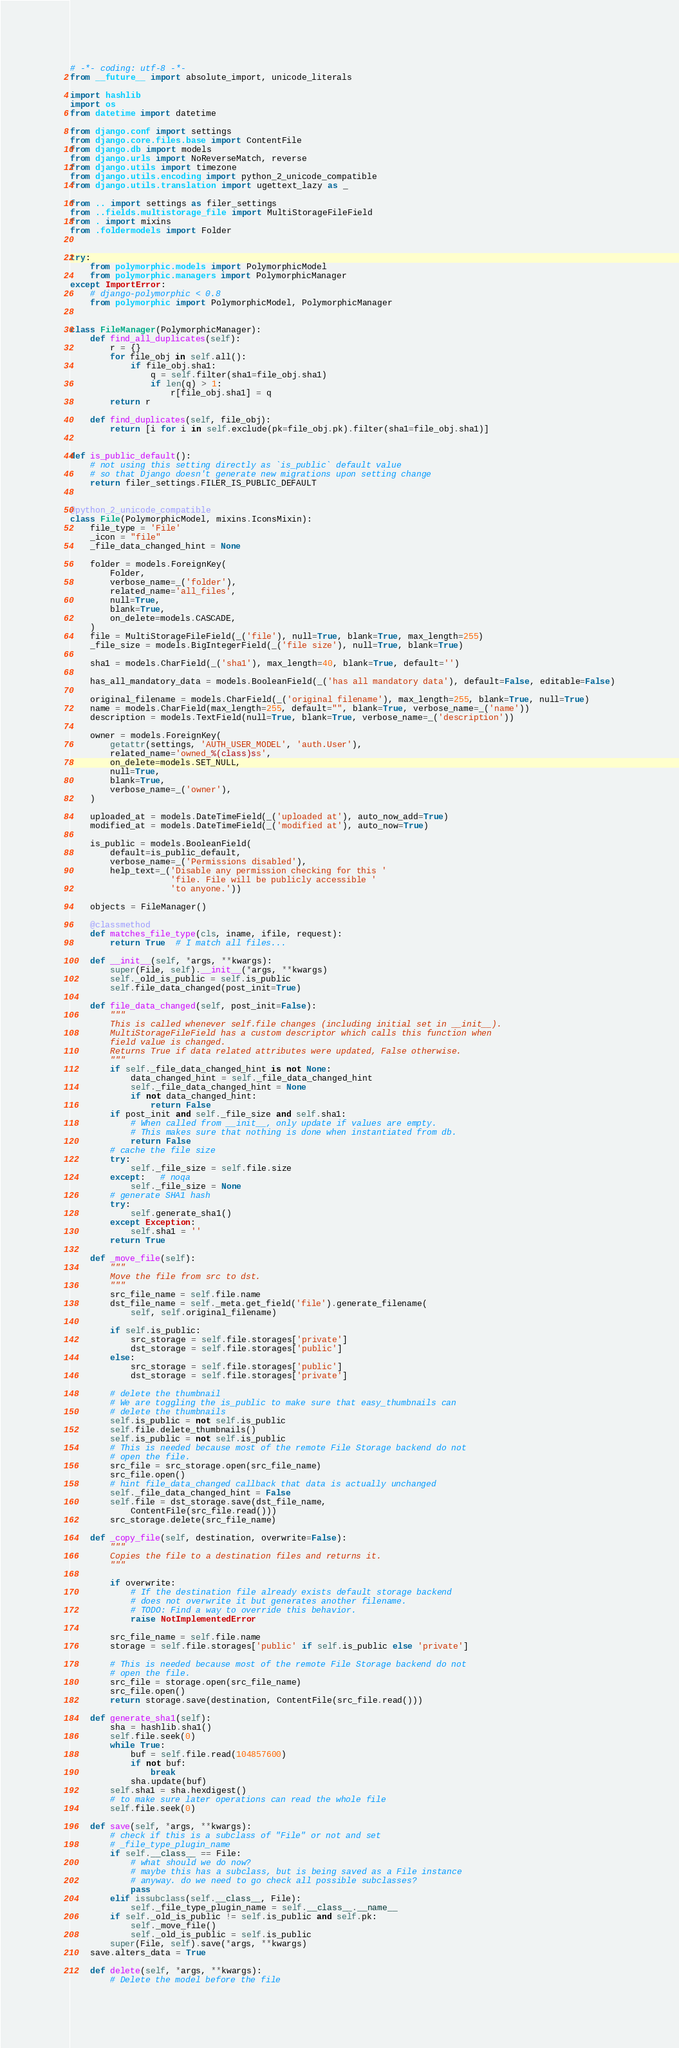<code> <loc_0><loc_0><loc_500><loc_500><_Python_># -*- coding: utf-8 -*-
from __future__ import absolute_import, unicode_literals

import hashlib
import os
from datetime import datetime

from django.conf import settings
from django.core.files.base import ContentFile
from django.db import models
from django.urls import NoReverseMatch, reverse
from django.utils import timezone
from django.utils.encoding import python_2_unicode_compatible
from django.utils.translation import ugettext_lazy as _

from .. import settings as filer_settings
from ..fields.multistorage_file import MultiStorageFileField
from . import mixins
from .foldermodels import Folder


try:
    from polymorphic.models import PolymorphicModel
    from polymorphic.managers import PolymorphicManager
except ImportError:
    # django-polymorphic < 0.8
    from polymorphic import PolymorphicModel, PolymorphicManager


class FileManager(PolymorphicManager):
    def find_all_duplicates(self):
        r = {}
        for file_obj in self.all():
            if file_obj.sha1:
                q = self.filter(sha1=file_obj.sha1)
                if len(q) > 1:
                    r[file_obj.sha1] = q
        return r

    def find_duplicates(self, file_obj):
        return [i for i in self.exclude(pk=file_obj.pk).filter(sha1=file_obj.sha1)]


def is_public_default():
    # not using this setting directly as `is_public` default value
    # so that Django doesn't generate new migrations upon setting change
    return filer_settings.FILER_IS_PUBLIC_DEFAULT


@python_2_unicode_compatible
class File(PolymorphicModel, mixins.IconsMixin):
    file_type = 'File'
    _icon = "file"
    _file_data_changed_hint = None

    folder = models.ForeignKey(
        Folder,
        verbose_name=_('folder'),
        related_name='all_files',
        null=True,
        blank=True,
        on_delete=models.CASCADE,
    )
    file = MultiStorageFileField(_('file'), null=True, blank=True, max_length=255)
    _file_size = models.BigIntegerField(_('file size'), null=True, blank=True)

    sha1 = models.CharField(_('sha1'), max_length=40, blank=True, default='')

    has_all_mandatory_data = models.BooleanField(_('has all mandatory data'), default=False, editable=False)

    original_filename = models.CharField(_('original filename'), max_length=255, blank=True, null=True)
    name = models.CharField(max_length=255, default="", blank=True, verbose_name=_('name'))
    description = models.TextField(null=True, blank=True, verbose_name=_('description'))

    owner = models.ForeignKey(
        getattr(settings, 'AUTH_USER_MODEL', 'auth.User'),
        related_name='owned_%(class)ss',
        on_delete=models.SET_NULL,
        null=True,
        blank=True,
        verbose_name=_('owner'),
    )

    uploaded_at = models.DateTimeField(_('uploaded at'), auto_now_add=True)
    modified_at = models.DateTimeField(_('modified at'), auto_now=True)

    is_public = models.BooleanField(
        default=is_public_default,
        verbose_name=_('Permissions disabled'),
        help_text=_('Disable any permission checking for this '
                    'file. File will be publicly accessible '
                    'to anyone.'))

    objects = FileManager()

    @classmethod
    def matches_file_type(cls, iname, ifile, request):
        return True  # I match all files...

    def __init__(self, *args, **kwargs):
        super(File, self).__init__(*args, **kwargs)
        self._old_is_public = self.is_public
        self.file_data_changed(post_init=True)

    def file_data_changed(self, post_init=False):
        """
        This is called whenever self.file changes (including initial set in __init__).
        MultiStorageFileField has a custom descriptor which calls this function when
        field value is changed.
        Returns True if data related attributes were updated, False otherwise.
        """
        if self._file_data_changed_hint is not None:
            data_changed_hint = self._file_data_changed_hint
            self._file_data_changed_hint = None
            if not data_changed_hint:
                return False
        if post_init and self._file_size and self.sha1:
            # When called from __init__, only update if values are empty.
            # This makes sure that nothing is done when instantiated from db.
            return False
        # cache the file size
        try:
            self._file_size = self.file.size
        except:   # noqa
            self._file_size = None
        # generate SHA1 hash
        try:
            self.generate_sha1()
        except Exception:
            self.sha1 = ''
        return True

    def _move_file(self):
        """
        Move the file from src to dst.
        """
        src_file_name = self.file.name
        dst_file_name = self._meta.get_field('file').generate_filename(
            self, self.original_filename)

        if self.is_public:
            src_storage = self.file.storages['private']
            dst_storage = self.file.storages['public']
        else:
            src_storage = self.file.storages['public']
            dst_storage = self.file.storages['private']

        # delete the thumbnail
        # We are toggling the is_public to make sure that easy_thumbnails can
        # delete the thumbnails
        self.is_public = not self.is_public
        self.file.delete_thumbnails()
        self.is_public = not self.is_public
        # This is needed because most of the remote File Storage backend do not
        # open the file.
        src_file = src_storage.open(src_file_name)
        src_file.open()
        # hint file_data_changed callback that data is actually unchanged
        self._file_data_changed_hint = False
        self.file = dst_storage.save(dst_file_name,
            ContentFile(src_file.read()))
        src_storage.delete(src_file_name)

    def _copy_file(self, destination, overwrite=False):
        """
        Copies the file to a destination files and returns it.
        """

        if overwrite:
            # If the destination file already exists default storage backend
            # does not overwrite it but generates another filename.
            # TODO: Find a way to override this behavior.
            raise NotImplementedError

        src_file_name = self.file.name
        storage = self.file.storages['public' if self.is_public else 'private']

        # This is needed because most of the remote File Storage backend do not
        # open the file.
        src_file = storage.open(src_file_name)
        src_file.open()
        return storage.save(destination, ContentFile(src_file.read()))

    def generate_sha1(self):
        sha = hashlib.sha1()
        self.file.seek(0)
        while True:
            buf = self.file.read(104857600)
            if not buf:
                break
            sha.update(buf)
        self.sha1 = sha.hexdigest()
        # to make sure later operations can read the whole file
        self.file.seek(0)

    def save(self, *args, **kwargs):
        # check if this is a subclass of "File" or not and set
        # _file_type_plugin_name
        if self.__class__ == File:
            # what should we do now?
            # maybe this has a subclass, but is being saved as a File instance
            # anyway. do we need to go check all possible subclasses?
            pass
        elif issubclass(self.__class__, File):
            self._file_type_plugin_name = self.__class__.__name__
        if self._old_is_public != self.is_public and self.pk:
            self._move_file()
            self._old_is_public = self.is_public
        super(File, self).save(*args, **kwargs)
    save.alters_data = True

    def delete(self, *args, **kwargs):
        # Delete the model before the file</code> 